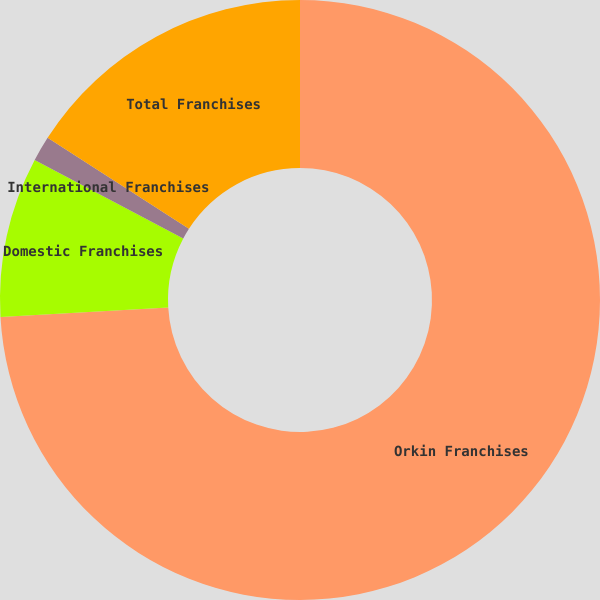<chart> <loc_0><loc_0><loc_500><loc_500><pie_chart><fcel>Orkin Franchises<fcel>Domestic Franchises<fcel>International Franchises<fcel>Total Franchises<nl><fcel>74.1%<fcel>8.63%<fcel>1.36%<fcel>15.91%<nl></chart> 